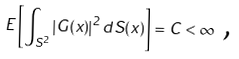Convert formula to latex. <formula><loc_0><loc_0><loc_500><loc_500>E \left [ \int _ { S ^ { 2 } } \left | G ( x ) \right | ^ { 2 } d S ( x ) \right ] = C < \infty \text { ,}</formula> 